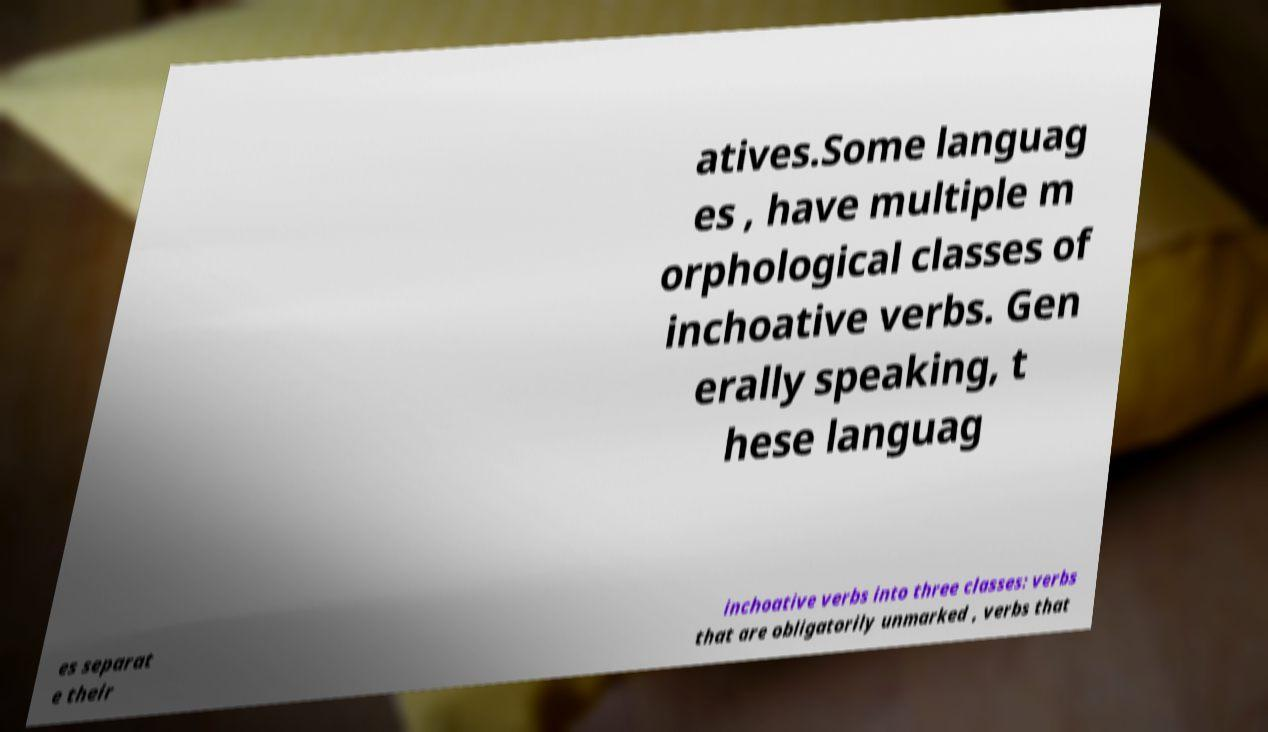Can you accurately transcribe the text from the provided image for me? atives.Some languag es , have multiple m orphological classes of inchoative verbs. Gen erally speaking, t hese languag es separat e their inchoative verbs into three classes: verbs that are obligatorily unmarked , verbs that 